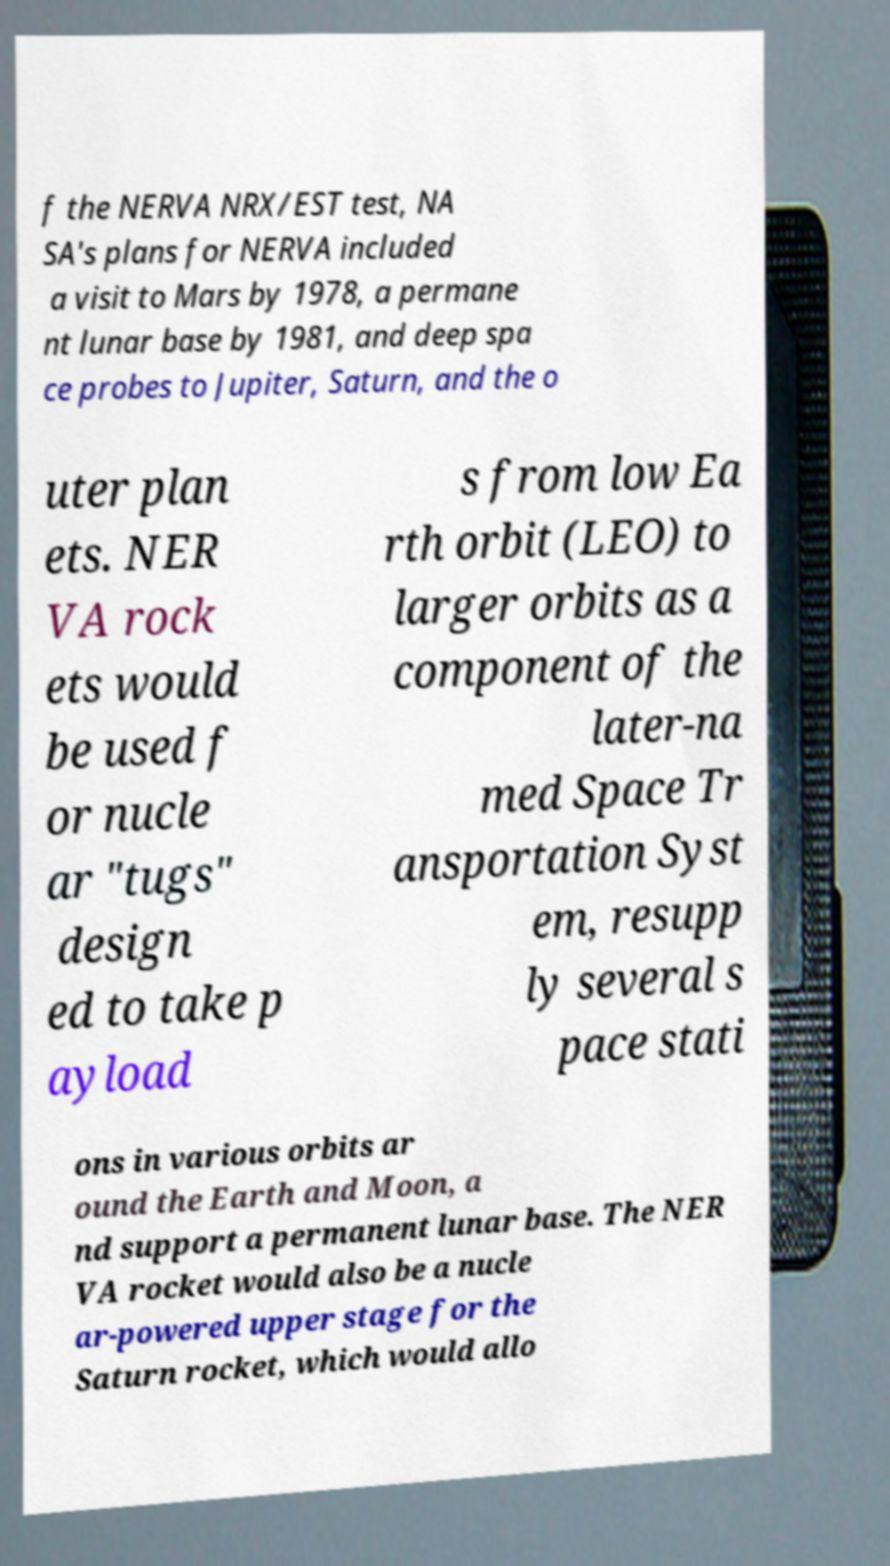Could you extract and type out the text from this image? f the NERVA NRX/EST test, NA SA's plans for NERVA included a visit to Mars by 1978, a permane nt lunar base by 1981, and deep spa ce probes to Jupiter, Saturn, and the o uter plan ets. NER VA rock ets would be used f or nucle ar "tugs" design ed to take p ayload s from low Ea rth orbit (LEO) to larger orbits as a component of the later-na med Space Tr ansportation Syst em, resupp ly several s pace stati ons in various orbits ar ound the Earth and Moon, a nd support a permanent lunar base. The NER VA rocket would also be a nucle ar-powered upper stage for the Saturn rocket, which would allo 